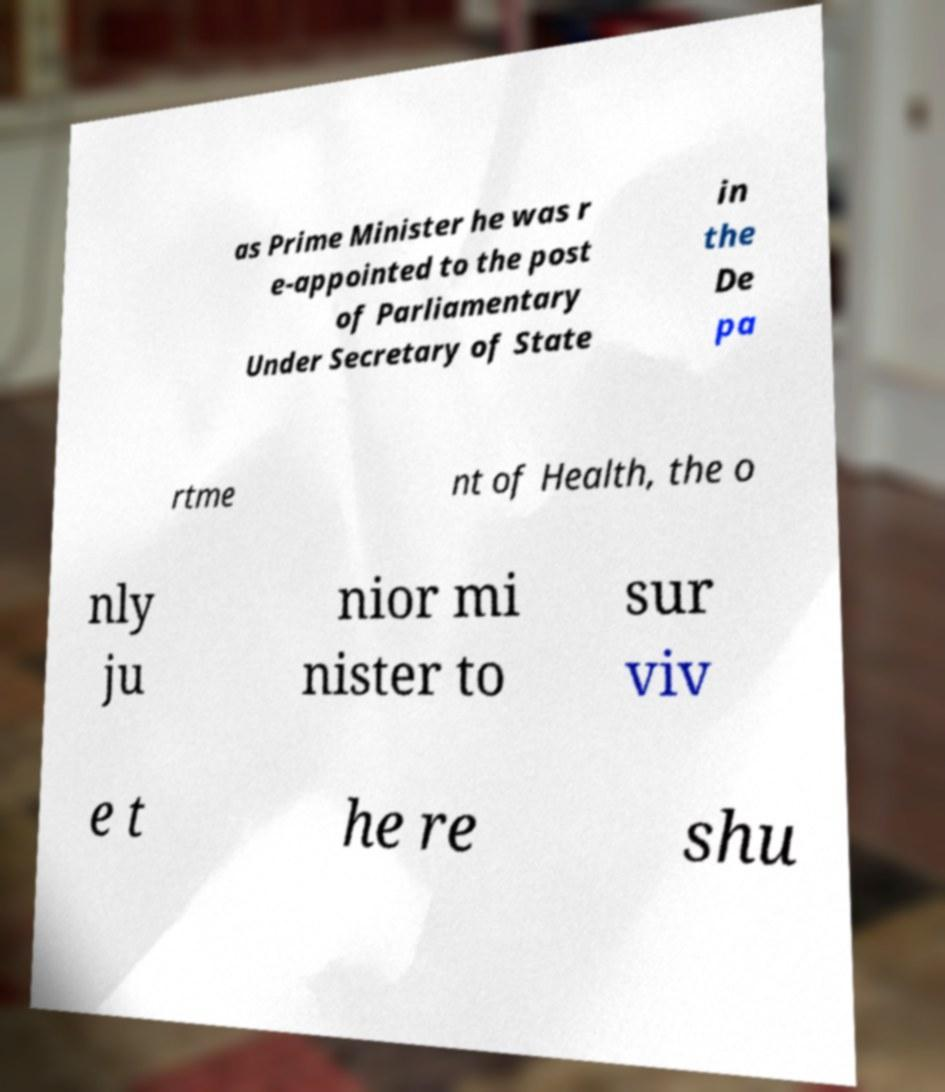Please identify and transcribe the text found in this image. as Prime Minister he was r e-appointed to the post of Parliamentary Under Secretary of State in the De pa rtme nt of Health, the o nly ju nior mi nister to sur viv e t he re shu 